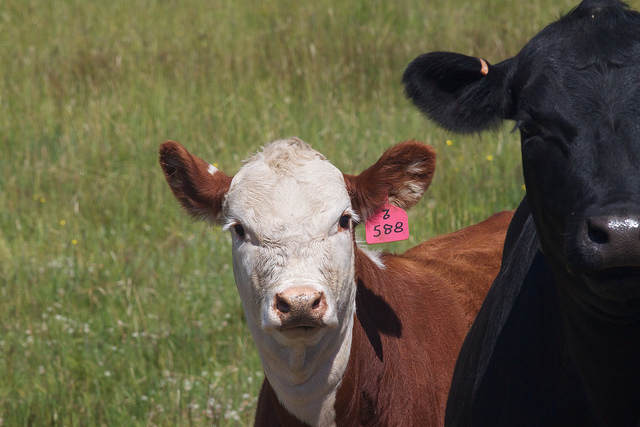<image>How was the lamp on the left marked? I don't know how the lamp on the left was marked. It might be tagged or numbered. How was the lamp on the left marked? It is not clear how the lamp on the left was marked. It can be seen with a tag or without a tag. 